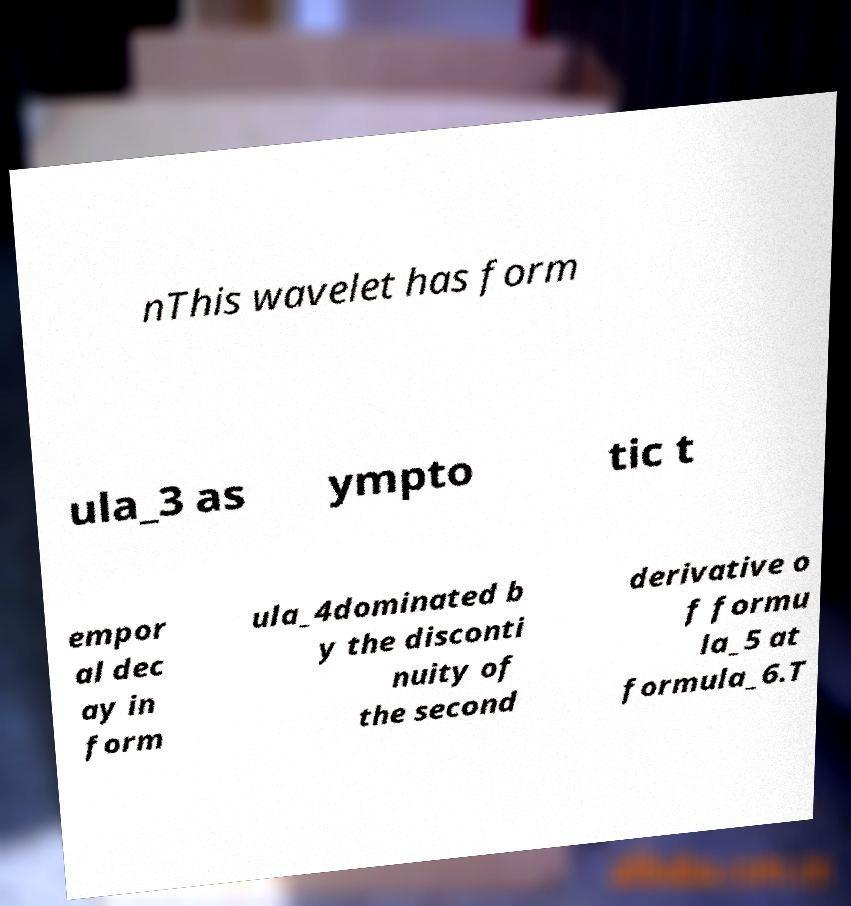There's text embedded in this image that I need extracted. Can you transcribe it verbatim? nThis wavelet has form ula_3 as ympto tic t empor al dec ay in form ula_4dominated b y the disconti nuity of the second derivative o f formu la_5 at formula_6.T 